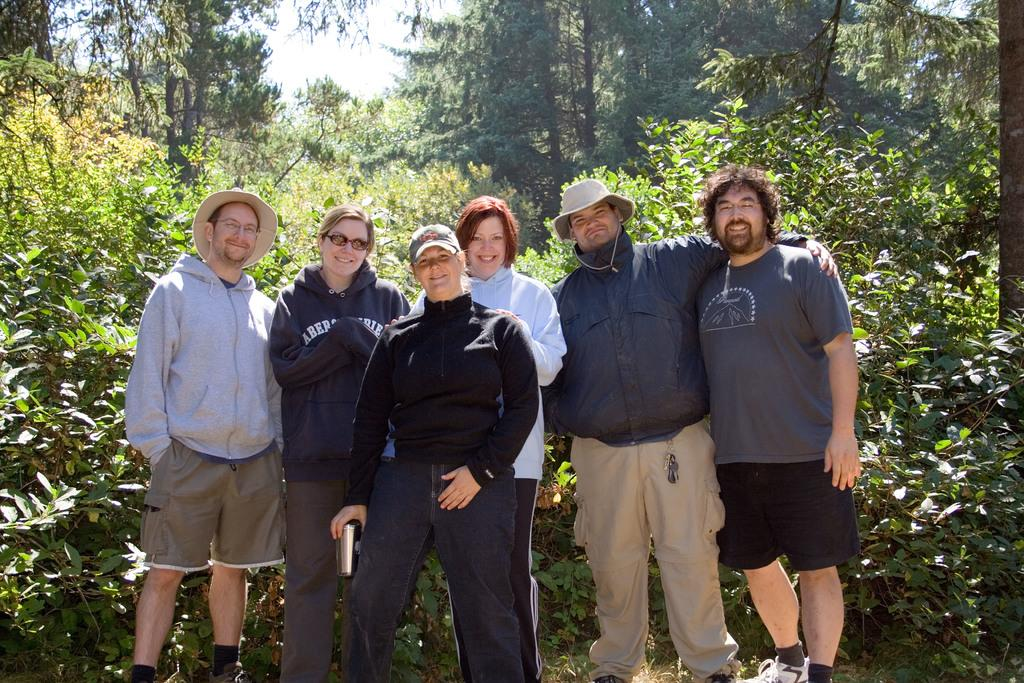What can be seen in the image? There are people standing in the image. What is visible in the background of the image? There are trees in the background of the image. What type of brain can be seen in the image? There is no brain visible in the image; it features people standing in front of trees. 